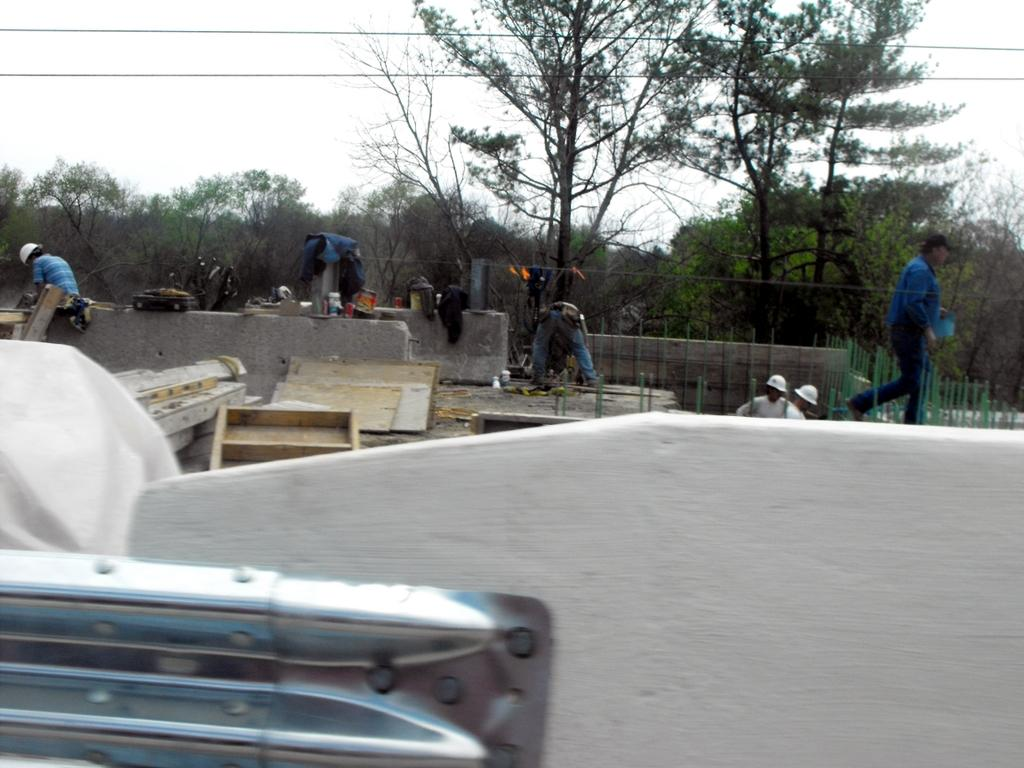Who or what is present in the image? There are people in the image. What are the people doing in the image? The people are doing something with wooden blocks. What can be seen in the background of the image? There are trees in the background of the image. What type of station can be seen in the image? There is no station present in the image. Can you see a bottle in the image? There is no bottle present in the image. 